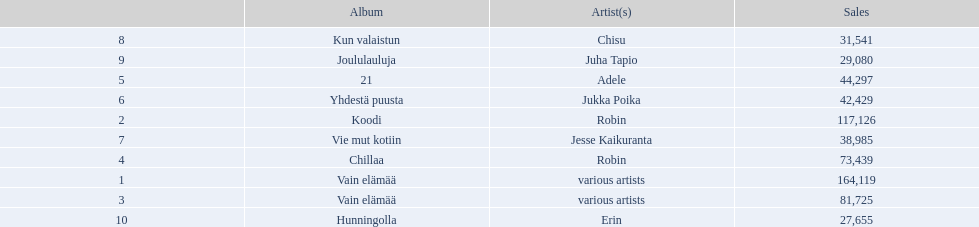Which artists' albums reached number one in finland during 2012? 164,119, 117,126, 81,725, 73,439, 44,297, 42,429, 38,985, 31,541, 29,080, 27,655. What were the sales figures of these albums? Various artists, robin, various artists, robin, adele, jukka poika, jesse kaikuranta, chisu, juha tapio, erin. And did adele or chisu have more sales during this period? Adele. Would you mind parsing the complete table? {'header': ['', 'Album', 'Artist(s)', 'Sales'], 'rows': [['8', 'Kun valaistun', 'Chisu', '31,541'], ['9', 'Joululauluja', 'Juha Tapio', '29,080'], ['5', '21', 'Adele', '44,297'], ['6', 'Yhdestä puusta', 'Jukka Poika', '42,429'], ['2', 'Koodi', 'Robin', '117,126'], ['7', 'Vie mut kotiin', 'Jesse Kaikuranta', '38,985'], ['4', 'Chillaa', 'Robin', '73,439'], ['1', 'Vain elämää', 'various artists', '164,119'], ['3', 'Vain elämää', 'various artists', '81,725'], ['10', 'Hunningolla', 'Erin', '27,655']]} 